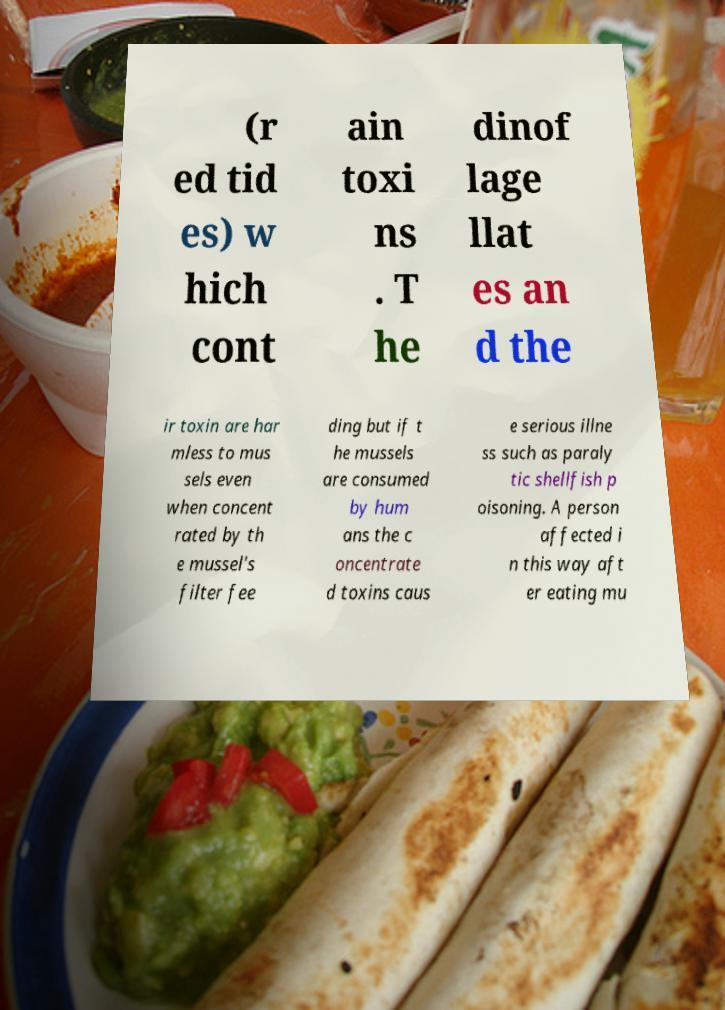There's text embedded in this image that I need extracted. Can you transcribe it verbatim? (r ed tid es) w hich cont ain toxi ns . T he dinof lage llat es an d the ir toxin are har mless to mus sels even when concent rated by th e mussel's filter fee ding but if t he mussels are consumed by hum ans the c oncentrate d toxins caus e serious illne ss such as paraly tic shellfish p oisoning. A person affected i n this way aft er eating mu 